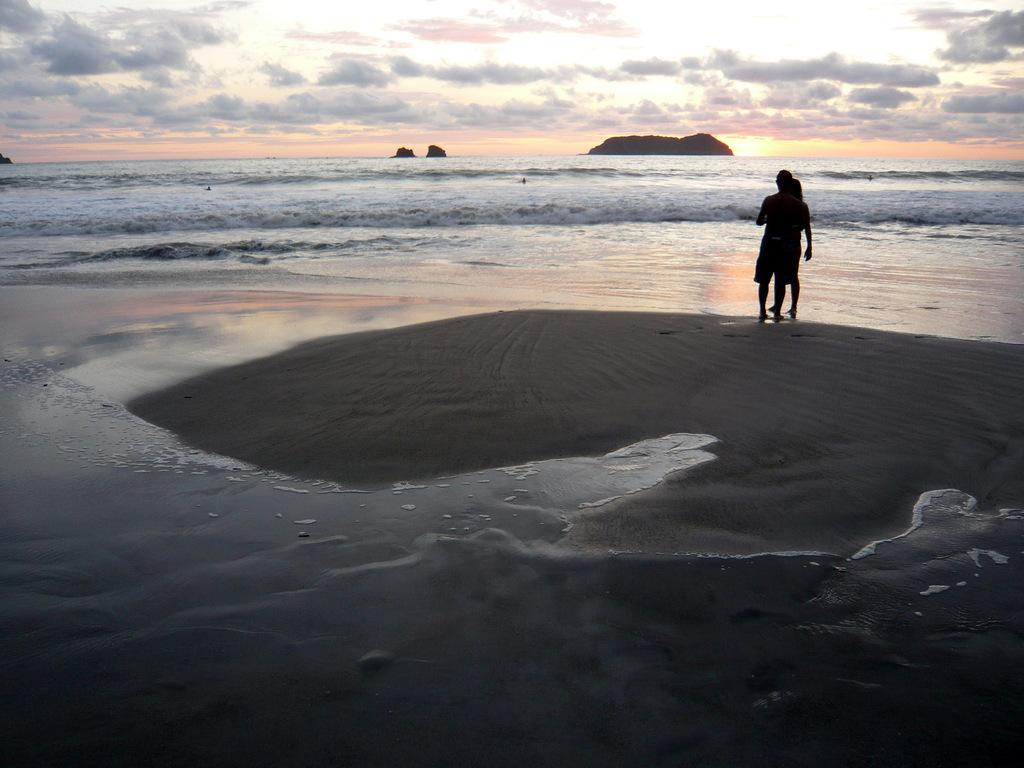How many people are in the image? There are two persons standing in the image. What type of natural features can be seen in the image? Rocks and water are visible in the image. What is the condition of the sky in the background of the image? The sky is cloudy in the background of the image. What type of lamp can be seen on the rocks in the image? There is no lamp present in the image; only rocks, water, and two persons are visible. 